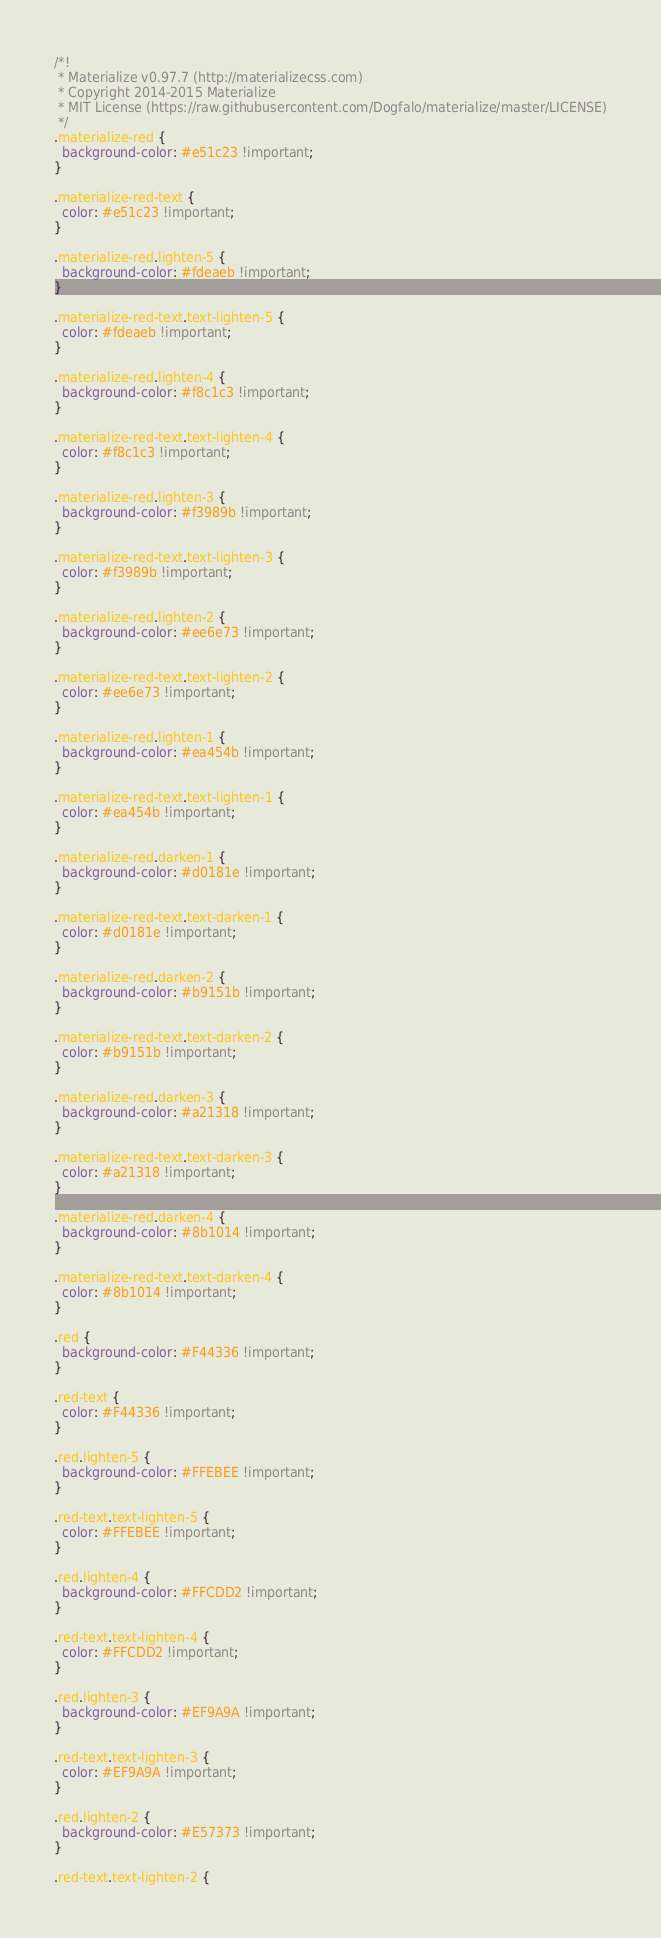<code> <loc_0><loc_0><loc_500><loc_500><_CSS_>/*!
 * Materialize v0.97.7 (http://materializecss.com)
 * Copyright 2014-2015 Materialize
 * MIT License (https://raw.githubusercontent.com/Dogfalo/materialize/master/LICENSE)
 */
.materialize-red {
  background-color: #e51c23 !important;
}

.materialize-red-text {
  color: #e51c23 !important;
}

.materialize-red.lighten-5 {
  background-color: #fdeaeb !important;
}

.materialize-red-text.text-lighten-5 {
  color: #fdeaeb !important;
}

.materialize-red.lighten-4 {
  background-color: #f8c1c3 !important;
}

.materialize-red-text.text-lighten-4 {
  color: #f8c1c3 !important;
}

.materialize-red.lighten-3 {
  background-color: #f3989b !important;
}

.materialize-red-text.text-lighten-3 {
  color: #f3989b !important;
}

.materialize-red.lighten-2 {
  background-color: #ee6e73 !important;
}

.materialize-red-text.text-lighten-2 {
  color: #ee6e73 !important;
}

.materialize-red.lighten-1 {
  background-color: #ea454b !important;
}

.materialize-red-text.text-lighten-1 {
  color: #ea454b !important;
}

.materialize-red.darken-1 {
  background-color: #d0181e !important;
}

.materialize-red-text.text-darken-1 {
  color: #d0181e !important;
}

.materialize-red.darken-2 {
  background-color: #b9151b !important;
}

.materialize-red-text.text-darken-2 {
  color: #b9151b !important;
}

.materialize-red.darken-3 {
  background-color: #a21318 !important;
}

.materialize-red-text.text-darken-3 {
  color: #a21318 !important;
}

.materialize-red.darken-4 {
  background-color: #8b1014 !important;
}

.materialize-red-text.text-darken-4 {
  color: #8b1014 !important;
}

.red {
  background-color: #F44336 !important;
}

.red-text {
  color: #F44336 !important;
}

.red.lighten-5 {
  background-color: #FFEBEE !important;
}

.red-text.text-lighten-5 {
  color: #FFEBEE !important;
}

.red.lighten-4 {
  background-color: #FFCDD2 !important;
}

.red-text.text-lighten-4 {
  color: #FFCDD2 !important;
}

.red.lighten-3 {
  background-color: #EF9A9A !important;
}

.red-text.text-lighten-3 {
  color: #EF9A9A !important;
}

.red.lighten-2 {
  background-color: #E57373 !important;
}

.red-text.text-lighten-2 {</code> 